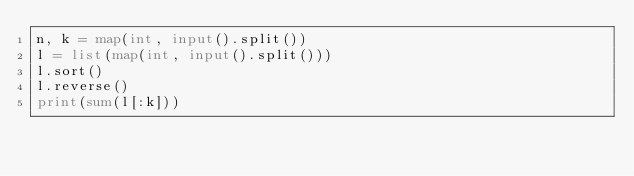Convert code to text. <code><loc_0><loc_0><loc_500><loc_500><_Python_>n, k = map(int, input().split())
l = list(map(int, input().split()))
l.sort()
l.reverse()
print(sum(l[:k]))
</code> 